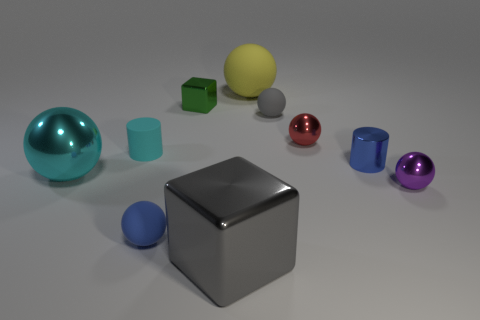Subtract all large shiny spheres. How many spheres are left? 5 Subtract all blue balls. How many balls are left? 5 Subtract 2 cubes. How many cubes are left? 0 Subtract all blocks. How many objects are left? 8 Subtract all green cubes. How many blue spheres are left? 1 Subtract all cyan spheres. Subtract all tiny blue rubber balls. How many objects are left? 8 Add 8 tiny cylinders. How many tiny cylinders are left? 10 Add 4 yellow things. How many yellow things exist? 5 Subtract 1 cyan spheres. How many objects are left? 9 Subtract all purple cylinders. Subtract all blue spheres. How many cylinders are left? 2 